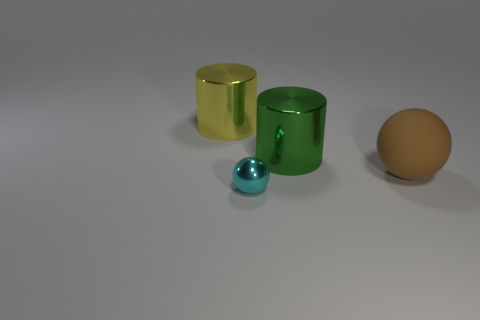Add 1 large rubber spheres. How many objects exist? 5 Add 4 cyan matte cylinders. How many cyan matte cylinders exist? 4 Subtract all green cylinders. How many cylinders are left? 1 Subtract 0 blue cylinders. How many objects are left? 4 Subtract 1 cylinders. How many cylinders are left? 1 Subtract all green spheres. Subtract all purple cylinders. How many spheres are left? 2 Subtract all gray cylinders. How many blue spheres are left? 0 Subtract all big purple shiny spheres. Subtract all shiny things. How many objects are left? 1 Add 3 large brown rubber things. How many large brown rubber things are left? 4 